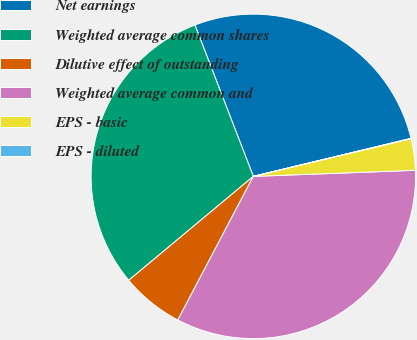Convert chart. <chart><loc_0><loc_0><loc_500><loc_500><pie_chart><fcel>Net earnings<fcel>Weighted average common shares<fcel>Dilutive effect of outstanding<fcel>Weighted average common and<fcel>EPS - basic<fcel>EPS - diluted<nl><fcel>27.09%<fcel>30.2%<fcel>6.23%<fcel>33.3%<fcel>3.13%<fcel>0.04%<nl></chart> 